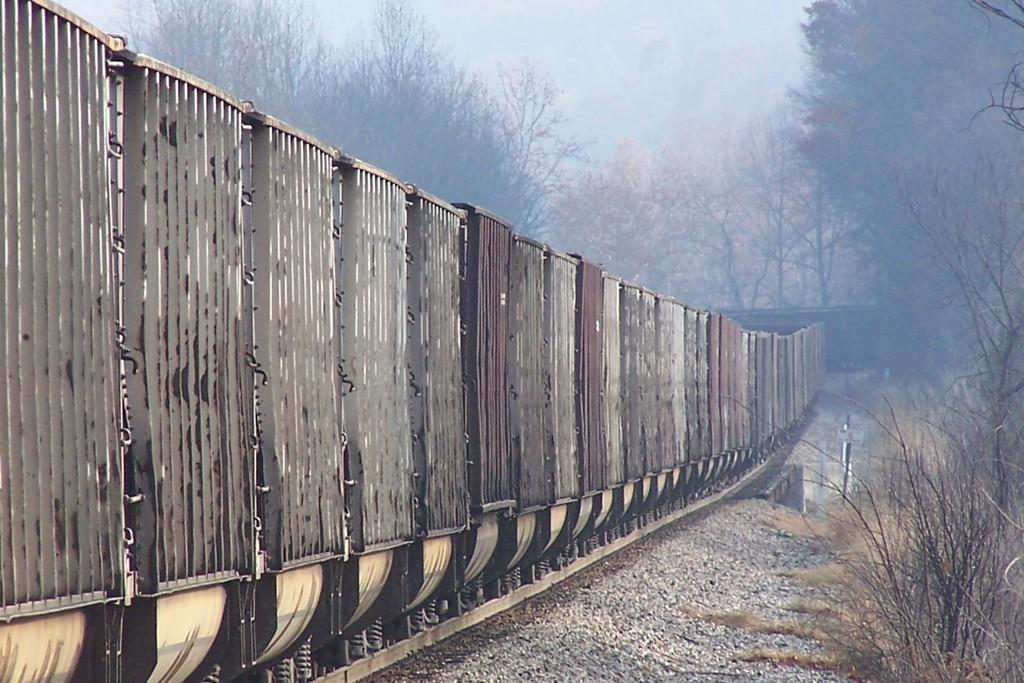What is the main subject of the image? The main subject of the image is a train. What is the train traveling on? The train is traveling on a railway track. What type of vegetation can be seen in the image? There are plants and trees in the image. What is visible in the background of the image? The sky is visible in the image. How many letters are visible on the train in the image? There are no letters visible on the train in the image. What type of calendar is hanging on the tree in the image? There is no calendar present in the image; it features a train, railway track, plants, trees, and sky. 